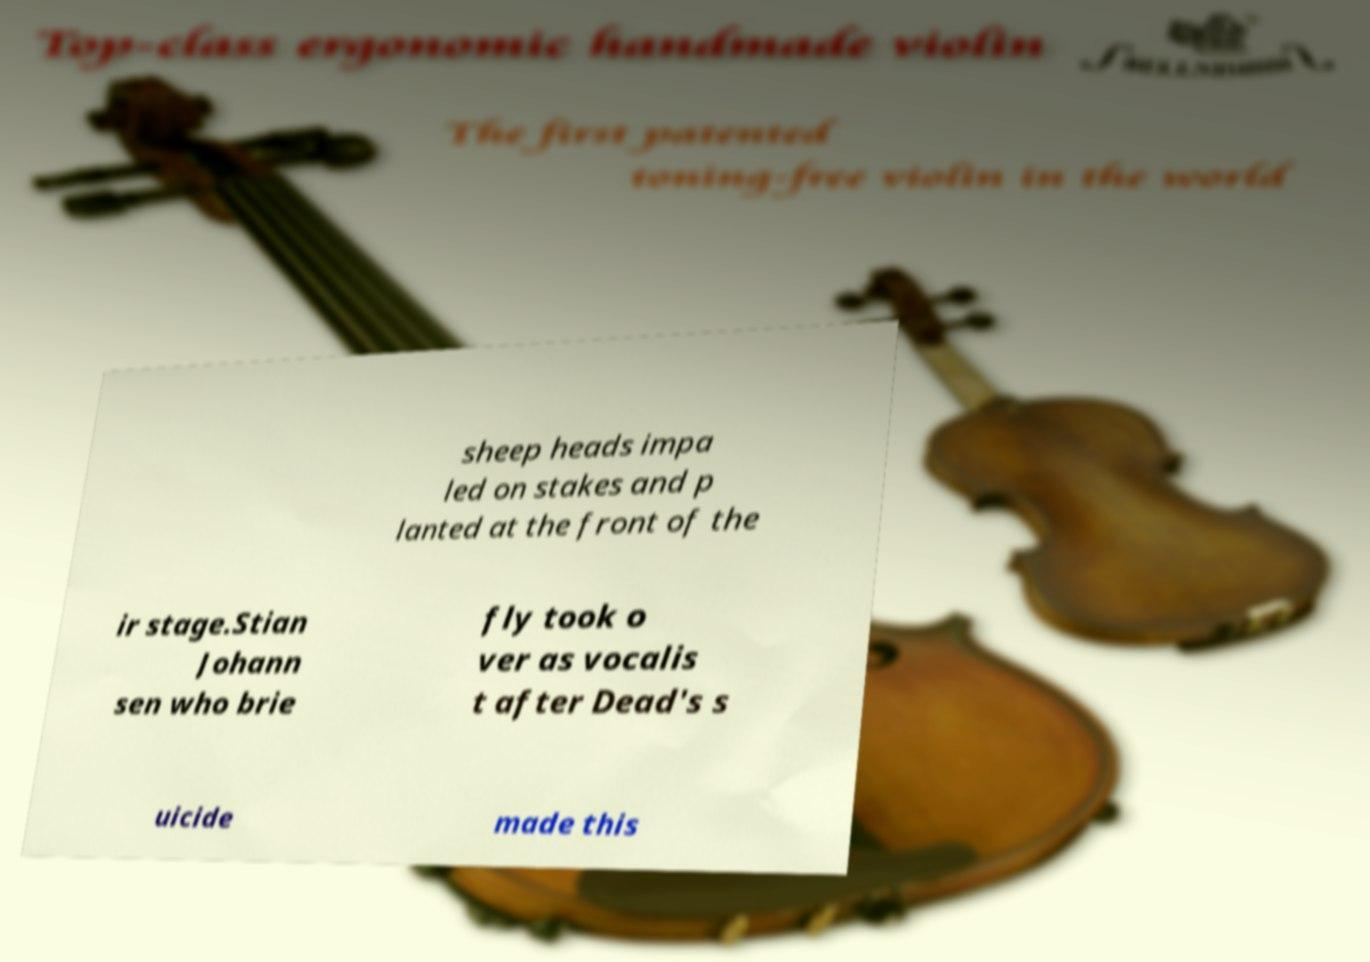What messages or text are displayed in this image? I need them in a readable, typed format. sheep heads impa led on stakes and p lanted at the front of the ir stage.Stian Johann sen who brie fly took o ver as vocalis t after Dead's s uicide made this 